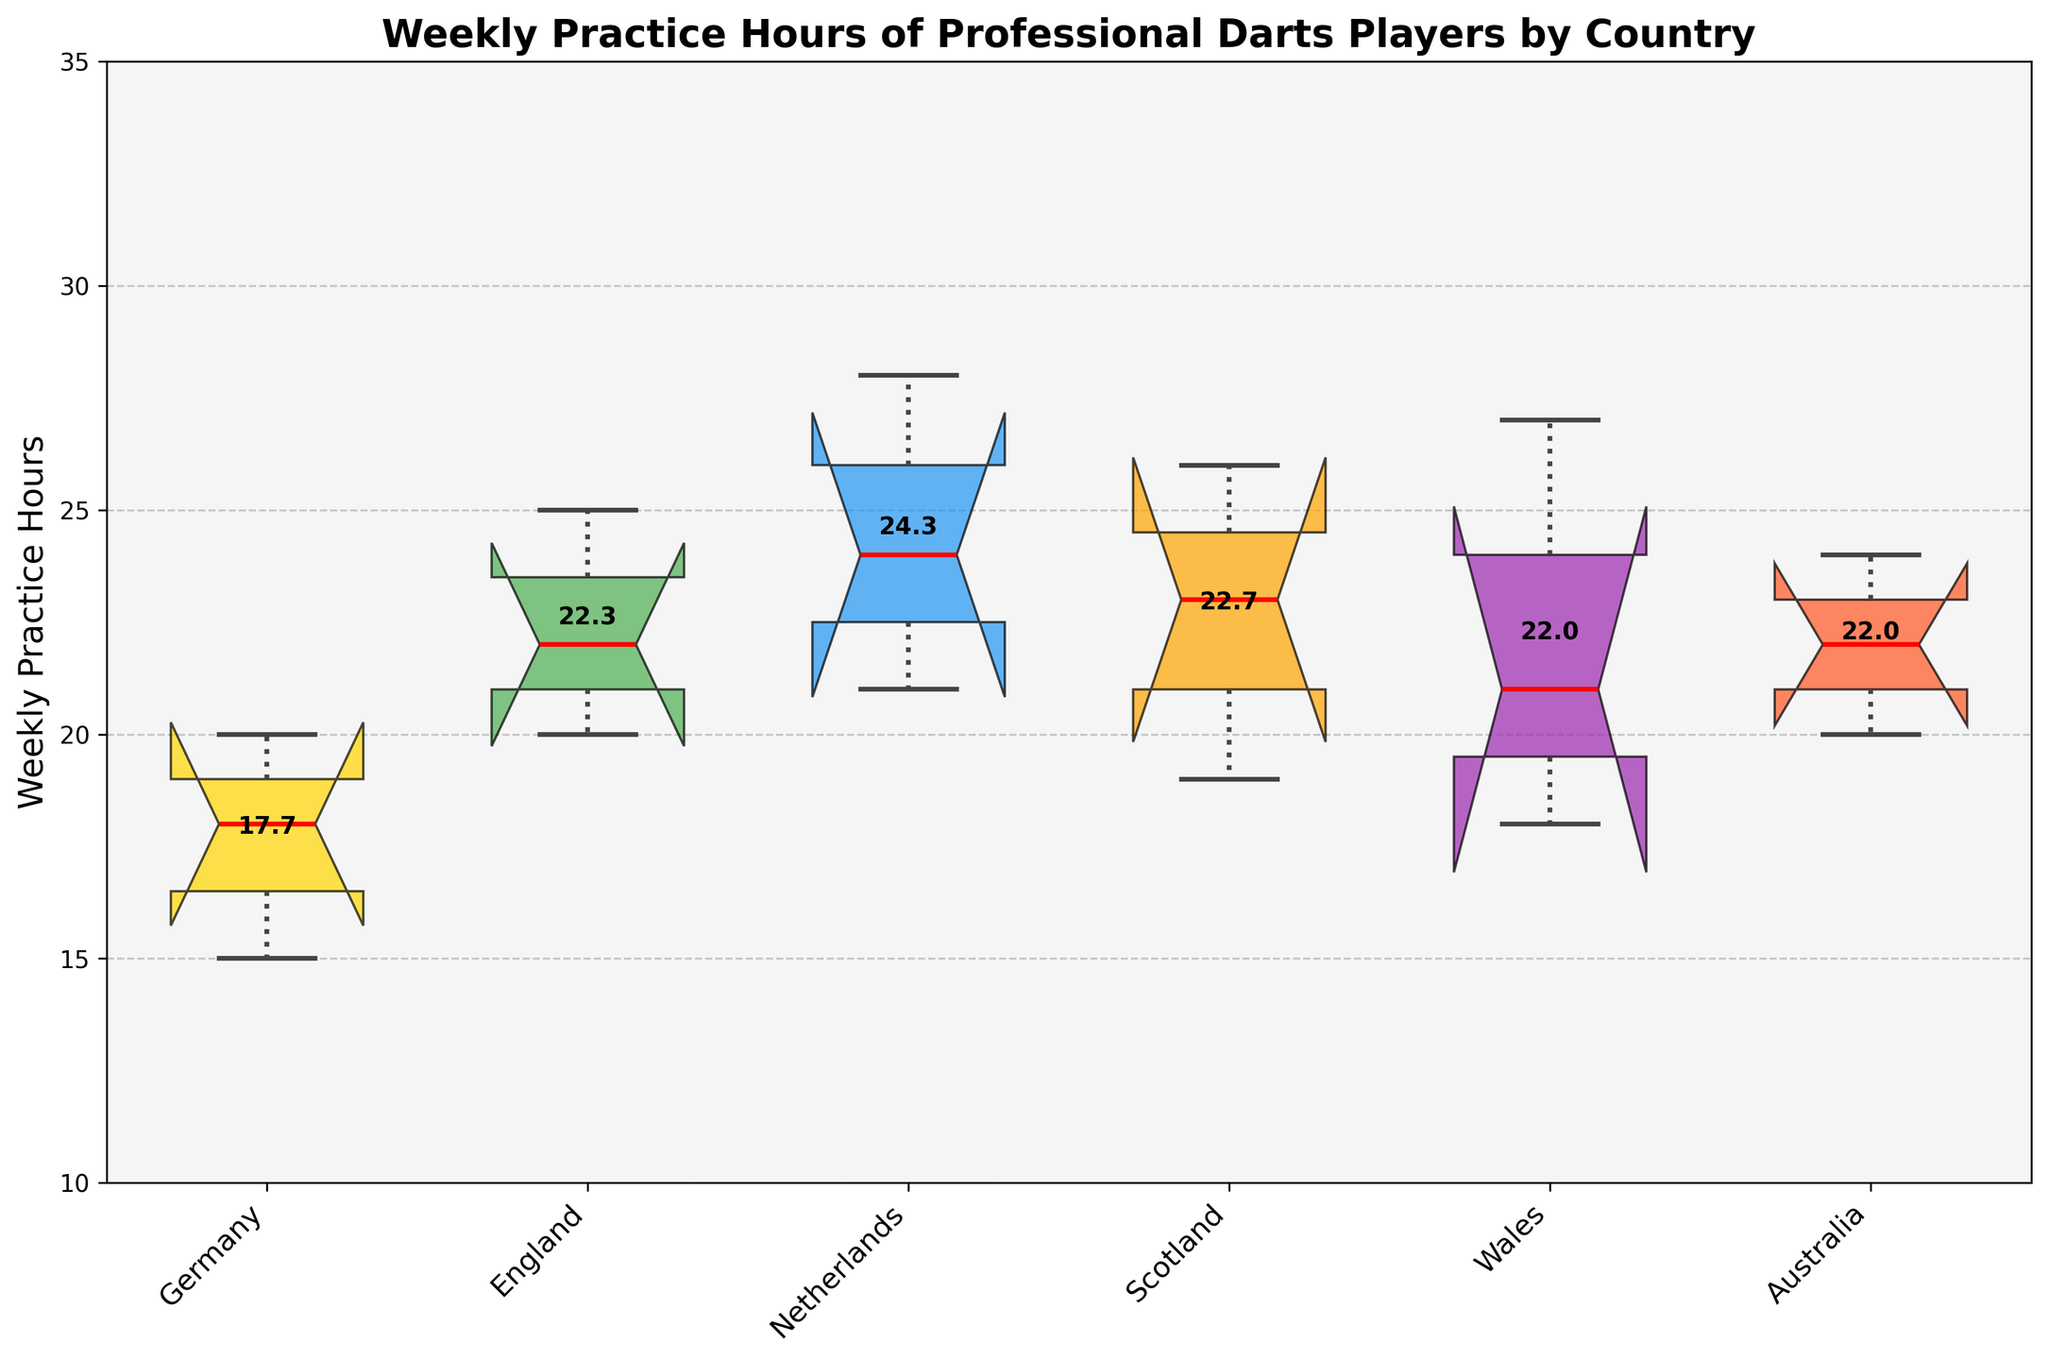What's the title of the figure? The title is usually located at the top of the figure. In this case, it reads: "Weekly Practice Hours of Professional Darts Players by Country".
Answer: Weekly Practice Hours of Professional Darts Players by Country Which country shows the highest median weekly practice hours? To find the median value, look for the red line inside each box. The highest median is indicated by the Netherlands.
Answer: Netherlands What is the interquartile range (IQR) for Germany? The IQR is the range between the lower quartile (bottom edge of the box) and the upper quartile (top edge of the box). For Germany, the IQR can be identified by observing the box: it spans from 15 to 20. So, IQR = 20 - 15 = 5.
Answer: 5 Which country has the widest spread in practice hours? The spread is indicated by the distance between the whiskers (lines extending from the top and bottom of the box). Here, the Netherlands shows the widest spread, from 21 to 28 hours.
Answer: Netherlands What is the median practice time for Wales? The median is represented by the red line within the box for each country. For Wales, the median practice time appears to be around 21 hours.
Answer: 21 How does the median practice time of England compare to that of Scotland? To compare, observe the red median lines of both countries. England has a median practice time of 22 hours, while Scotland has a median practice time of 23 hours. Thus, Scotland's median is slightly higher.
Answer: Scotland's median is higher Are there any countries with outliers in the data? Outliers are represented by individual points outside the whiskers. None of the countries display outliers in this dataset.
Answer: No What is the mean practice time for Australian players? The mean value is marked by the bold text above each country's notched box plot. For Australia, it is approximately 22 hours.
Answer: 22 Estimate the range of practice hours for Scotland based on the box plot. The range is identified by the lowest and highest values represented by the whiskers. For Scotland, the range starts at around 19 hours and goes up to around 26 hours. So, the range is 19 - 26 hours.
Answer: 19 - 26 hours 